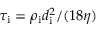Convert formula to latex. <formula><loc_0><loc_0><loc_500><loc_500>\tau _ { i } = \rho _ { i } d _ { i } ^ { 2 } / ( 1 8 \eta )</formula> 